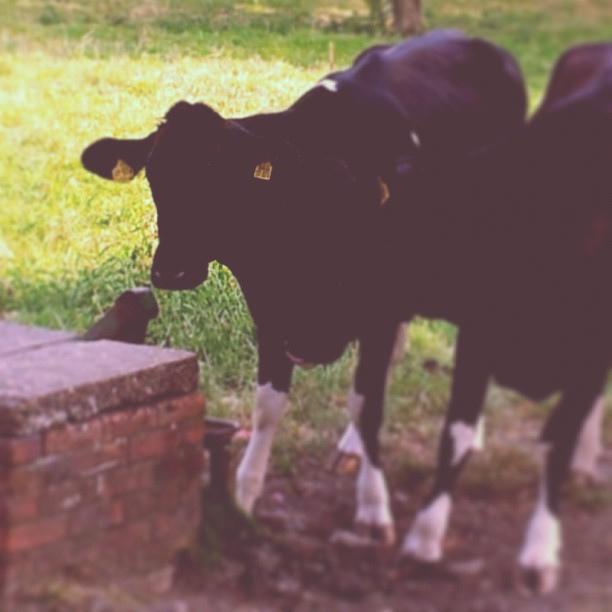How many cows are there?
Give a very brief answer. 2. How many cows are in the picture?
Give a very brief answer. 2. How many horses are there?
Give a very brief answer. 0. 